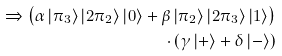Convert formula to latex. <formula><loc_0><loc_0><loc_500><loc_500>\Rightarrow \left ( \alpha \left | \pi _ { 3 } \right > \left | 2 \pi _ { 2 } \right > \left | 0 \right > + \beta \left | \pi _ { 2 } \right > \left | 2 \pi _ { 3 } \right > \left | 1 \right > \right ) \\ \cdot \left ( \gamma \left | + \right > + \delta \left | - \right > \right )</formula> 